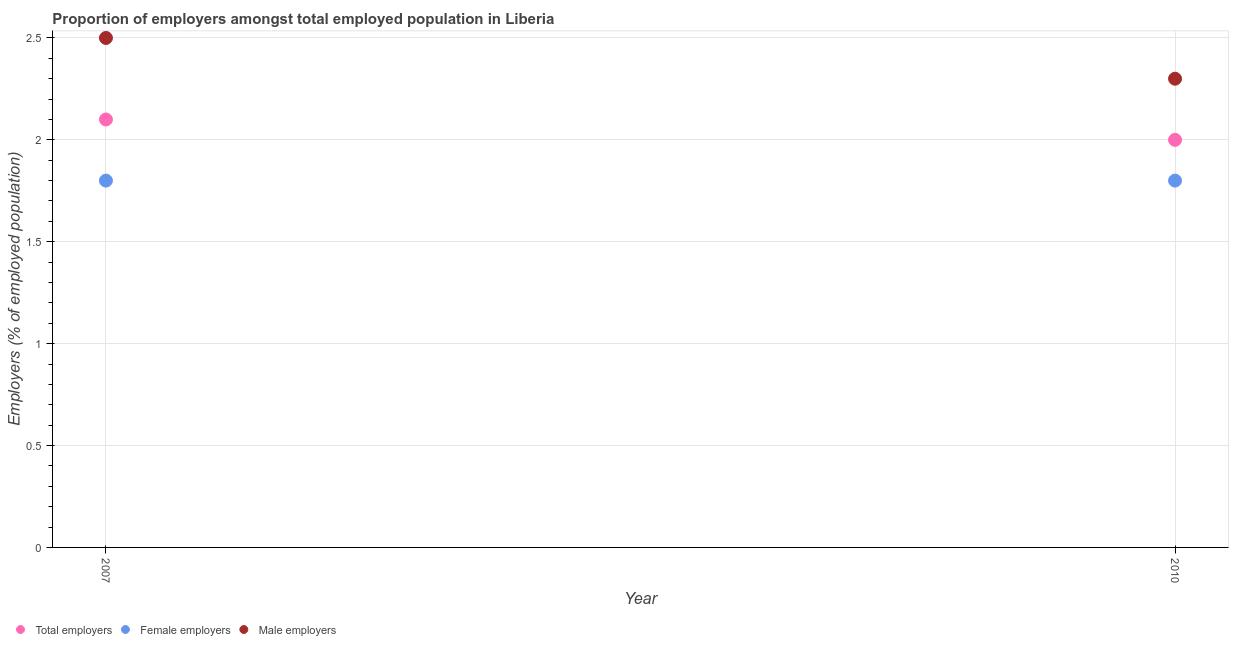Is the number of dotlines equal to the number of legend labels?
Your answer should be compact. Yes. What is the percentage of male employers in 2010?
Your response must be concise. 2.3. Across all years, what is the maximum percentage of female employers?
Make the answer very short. 1.8. Across all years, what is the minimum percentage of female employers?
Your answer should be very brief. 1.8. In which year was the percentage of total employers maximum?
Your answer should be very brief. 2007. What is the total percentage of female employers in the graph?
Offer a very short reply. 3.6. What is the difference between the percentage of total employers in 2007 and the percentage of male employers in 2010?
Your answer should be compact. -0.2. What is the average percentage of total employers per year?
Make the answer very short. 2.05. In the year 2007, what is the difference between the percentage of male employers and percentage of total employers?
Your answer should be very brief. 0.4. In how many years, is the percentage of male employers greater than 2 %?
Provide a succinct answer. 2. What is the ratio of the percentage of total employers in 2007 to that in 2010?
Offer a terse response. 1.05. Is the percentage of male employers in 2007 less than that in 2010?
Your response must be concise. No. In how many years, is the percentage of female employers greater than the average percentage of female employers taken over all years?
Offer a terse response. 0. Does the percentage of total employers monotonically increase over the years?
Your answer should be very brief. No. Is the percentage of female employers strictly greater than the percentage of male employers over the years?
Make the answer very short. No. What is the difference between two consecutive major ticks on the Y-axis?
Your answer should be compact. 0.5. Does the graph contain grids?
Your answer should be very brief. Yes. How many legend labels are there?
Provide a succinct answer. 3. How are the legend labels stacked?
Your answer should be very brief. Horizontal. What is the title of the graph?
Provide a short and direct response. Proportion of employers amongst total employed population in Liberia. Does "Ages 15-20" appear as one of the legend labels in the graph?
Provide a succinct answer. No. What is the label or title of the Y-axis?
Offer a very short reply. Employers (% of employed population). What is the Employers (% of employed population) in Total employers in 2007?
Make the answer very short. 2.1. What is the Employers (% of employed population) of Female employers in 2007?
Your response must be concise. 1.8. What is the Employers (% of employed population) in Female employers in 2010?
Your answer should be compact. 1.8. What is the Employers (% of employed population) of Male employers in 2010?
Give a very brief answer. 2.3. Across all years, what is the maximum Employers (% of employed population) of Total employers?
Provide a short and direct response. 2.1. Across all years, what is the maximum Employers (% of employed population) of Female employers?
Provide a succinct answer. 1.8. Across all years, what is the maximum Employers (% of employed population) in Male employers?
Offer a terse response. 2.5. Across all years, what is the minimum Employers (% of employed population) of Total employers?
Keep it short and to the point. 2. Across all years, what is the minimum Employers (% of employed population) in Female employers?
Your answer should be compact. 1.8. Across all years, what is the minimum Employers (% of employed population) in Male employers?
Provide a short and direct response. 2.3. What is the total Employers (% of employed population) of Total employers in the graph?
Your answer should be very brief. 4.1. What is the total Employers (% of employed population) of Female employers in the graph?
Your response must be concise. 3.6. What is the total Employers (% of employed population) in Male employers in the graph?
Your response must be concise. 4.8. What is the difference between the Employers (% of employed population) of Total employers in 2007 and that in 2010?
Your response must be concise. 0.1. What is the difference between the Employers (% of employed population) of Female employers in 2007 and that in 2010?
Keep it short and to the point. 0. What is the difference between the Employers (% of employed population) in Male employers in 2007 and that in 2010?
Offer a very short reply. 0.2. What is the difference between the Employers (% of employed population) in Total employers in 2007 and the Employers (% of employed population) in Female employers in 2010?
Offer a terse response. 0.3. What is the average Employers (% of employed population) of Total employers per year?
Your answer should be compact. 2.05. What is the average Employers (% of employed population) in Male employers per year?
Offer a very short reply. 2.4. In the year 2007, what is the difference between the Employers (% of employed population) of Female employers and Employers (% of employed population) of Male employers?
Give a very brief answer. -0.7. In the year 2010, what is the difference between the Employers (% of employed population) of Total employers and Employers (% of employed population) of Female employers?
Make the answer very short. 0.2. In the year 2010, what is the difference between the Employers (% of employed population) of Total employers and Employers (% of employed population) of Male employers?
Offer a very short reply. -0.3. In the year 2010, what is the difference between the Employers (% of employed population) of Female employers and Employers (% of employed population) of Male employers?
Your response must be concise. -0.5. What is the ratio of the Employers (% of employed population) of Total employers in 2007 to that in 2010?
Provide a short and direct response. 1.05. What is the ratio of the Employers (% of employed population) of Male employers in 2007 to that in 2010?
Your answer should be very brief. 1.09. What is the difference between the highest and the second highest Employers (% of employed population) in Total employers?
Your answer should be very brief. 0.1. What is the difference between the highest and the second highest Employers (% of employed population) in Male employers?
Your answer should be compact. 0.2. What is the difference between the highest and the lowest Employers (% of employed population) in Female employers?
Provide a short and direct response. 0. What is the difference between the highest and the lowest Employers (% of employed population) of Male employers?
Provide a succinct answer. 0.2. 